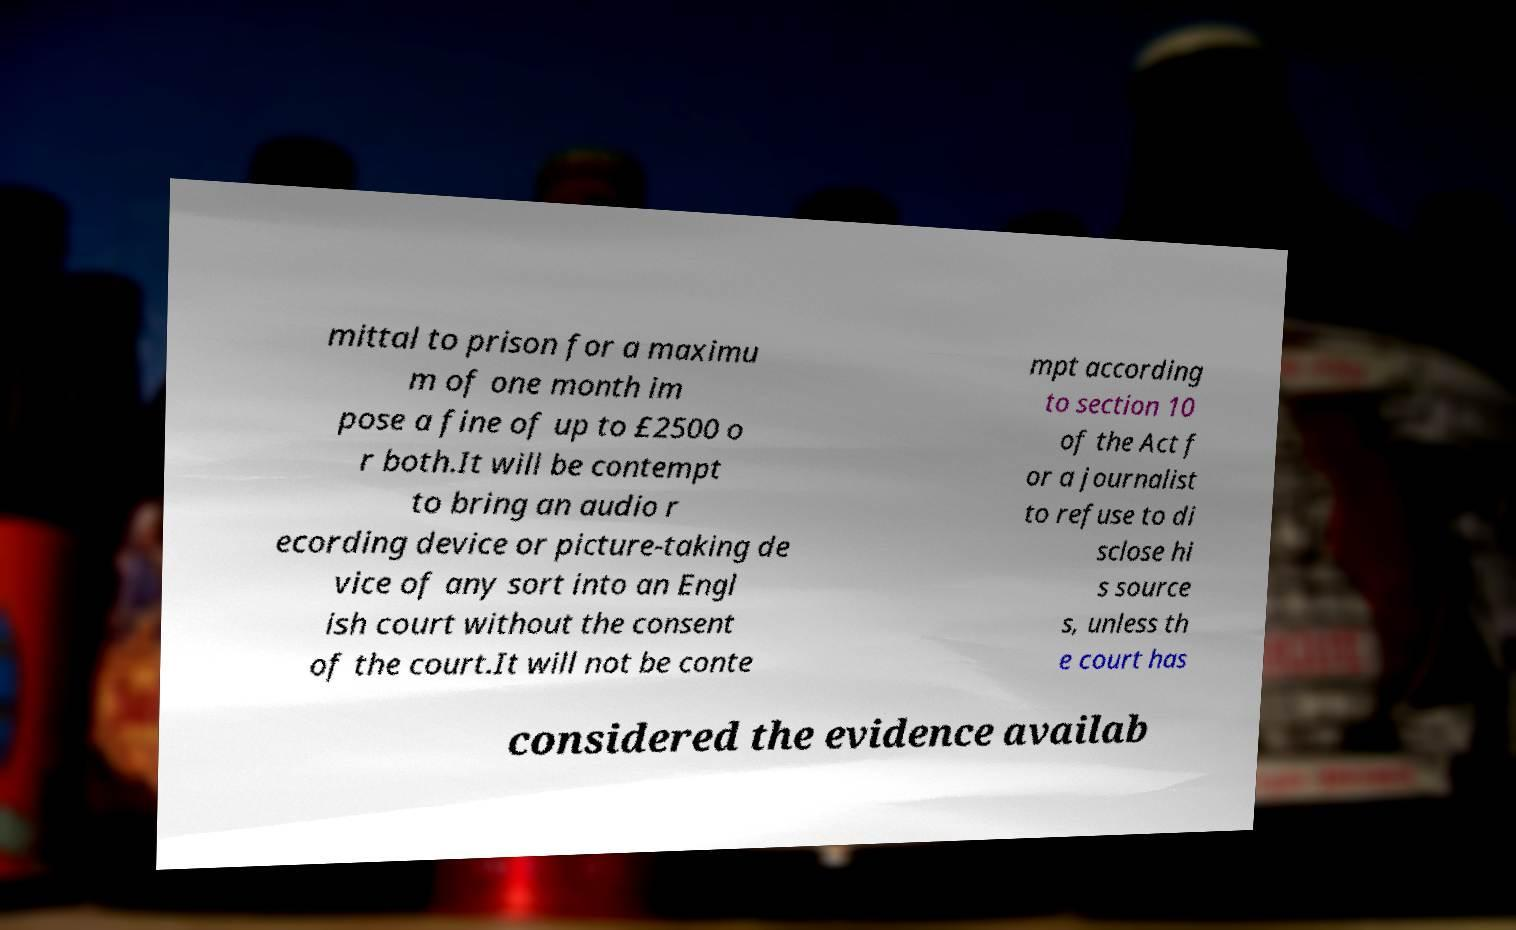There's text embedded in this image that I need extracted. Can you transcribe it verbatim? mittal to prison for a maximu m of one month im pose a fine of up to £2500 o r both.It will be contempt to bring an audio r ecording device or picture-taking de vice of any sort into an Engl ish court without the consent of the court.It will not be conte mpt according to section 10 of the Act f or a journalist to refuse to di sclose hi s source s, unless th e court has considered the evidence availab 